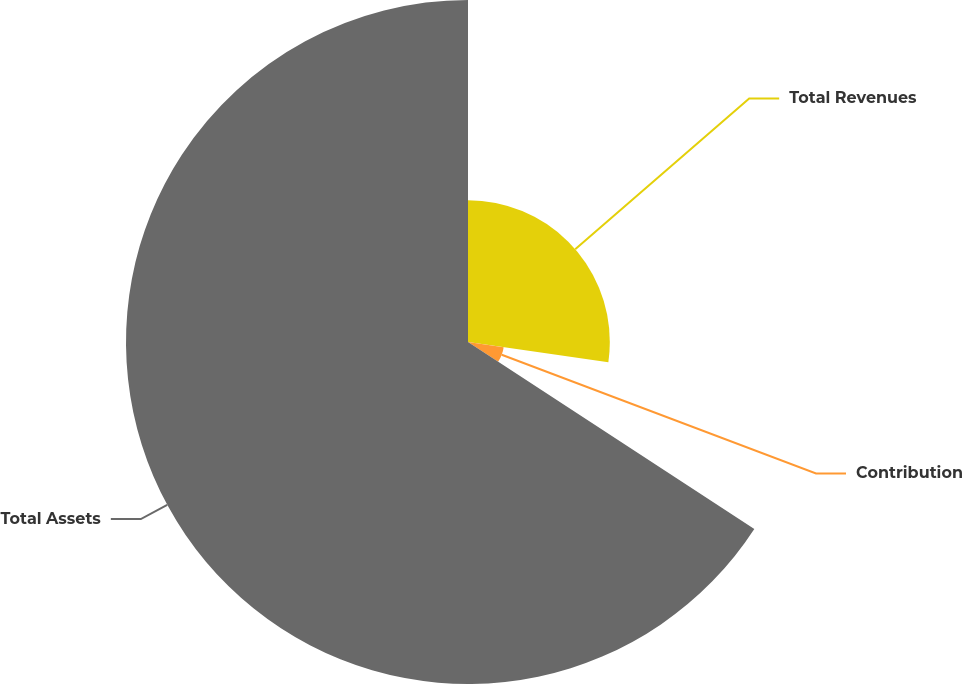Convert chart to OTSL. <chart><loc_0><loc_0><loc_500><loc_500><pie_chart><fcel>Total Revenues<fcel>Contribution<fcel>Total Assets<nl><fcel>27.28%<fcel>6.93%<fcel>65.79%<nl></chart> 